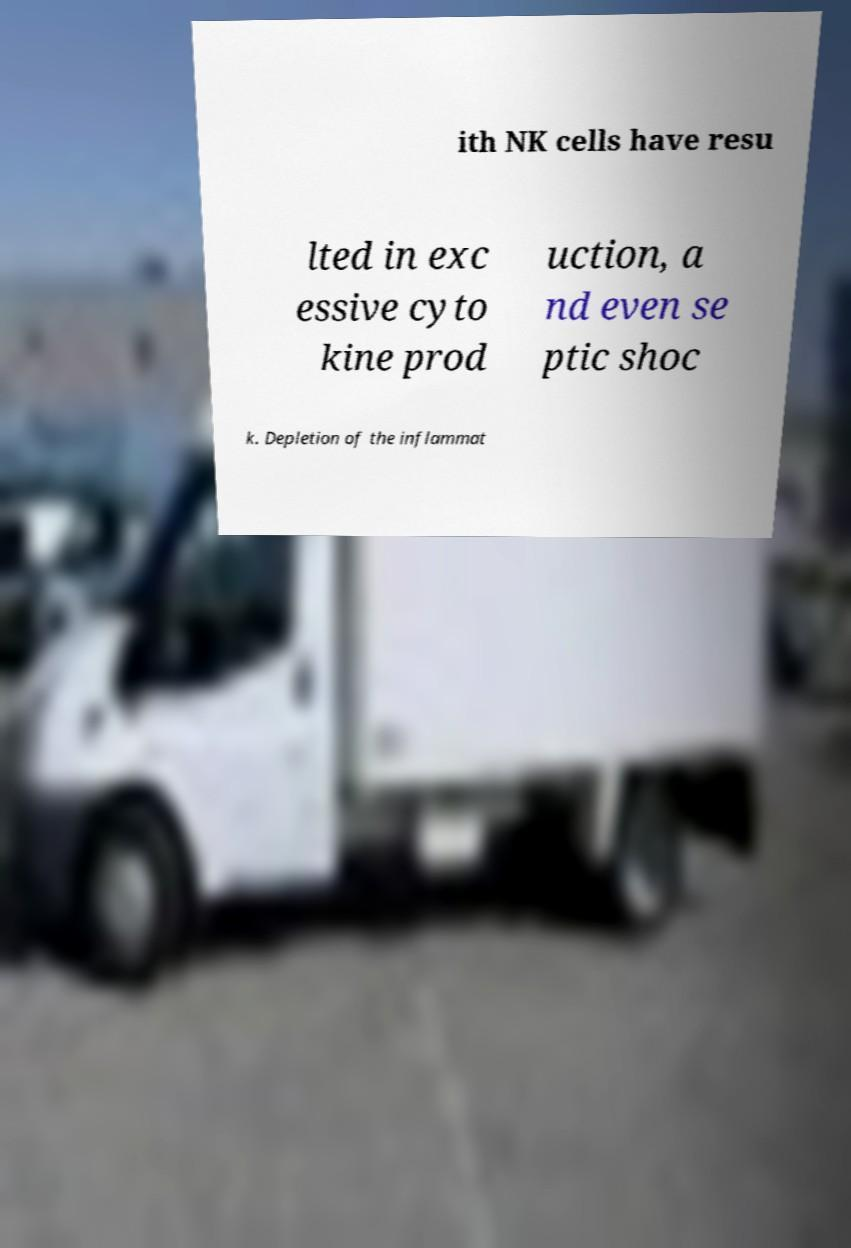What messages or text are displayed in this image? I need them in a readable, typed format. ith NK cells have resu lted in exc essive cyto kine prod uction, a nd even se ptic shoc k. Depletion of the inflammat 